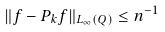Convert formula to latex. <formula><loc_0><loc_0><loc_500><loc_500>\| f - P _ { k } f \| _ { L _ { \infty } ( Q ) } \leq n ^ { - 1 }</formula> 